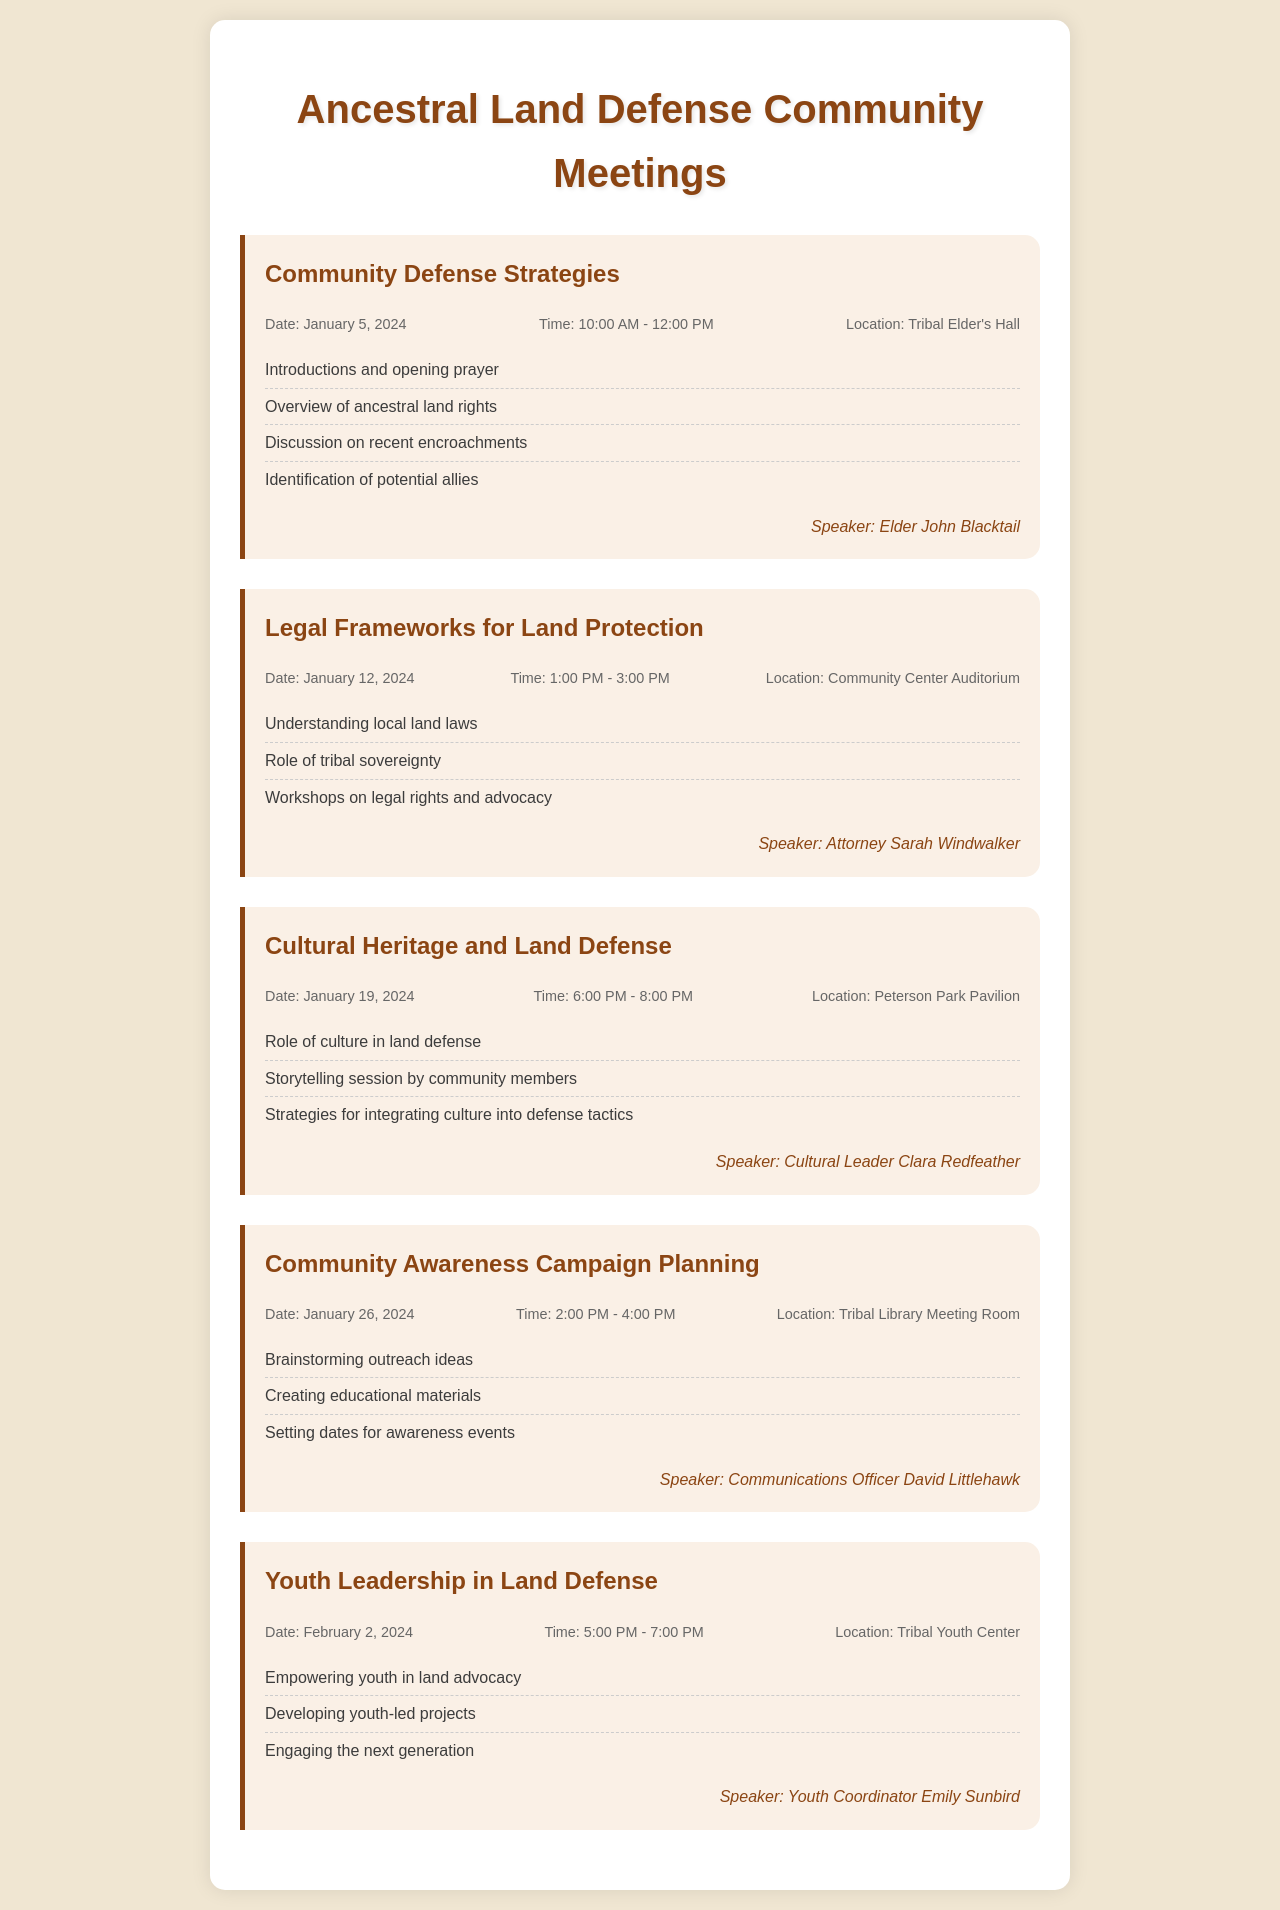What is the date of the first meeting? The first meeting is titled "Community Defense Strategies," which is held on January 5, 2024.
Answer: January 5, 2024 Who is the speaker for the meeting on legal frameworks? The meeting on legal frameworks is hosted by Attorney Sarah Windwalker.
Answer: Attorney Sarah Windwalker What location is the Youth Leadership meeting held at? The Youth Leadership in Land Defense meeting takes place at the Tribal Youth Center.
Answer: Tribal Youth Center What time does the Cultural Heritage meeting start? The meeting about Cultural Heritage starts at 6:00 PM on January 19, 2024.
Answer: 6:00 PM How many meetings are scheduled in January 2024? There are four meetings scheduled in January 2024.
Answer: Four What is the main agenda item for the Community Awareness Campaign Planning meeting? The main agenda item includes brainstorming outreach ideas to increase awareness within the community.
Answer: Brainstorming outreach ideas What is the focus of the "Youth Leadership in Land Defense" meeting? This meeting focuses on empowering youth in land advocacy and engaging the next generation in these efforts.
Answer: Empowering youth in land advocacy Who will lead the storytelling session during the Cultural Heritage meeting? The storytelling session will be led by community members, guided by Cultural Leader Clara Redfeather.
Answer: Community members 